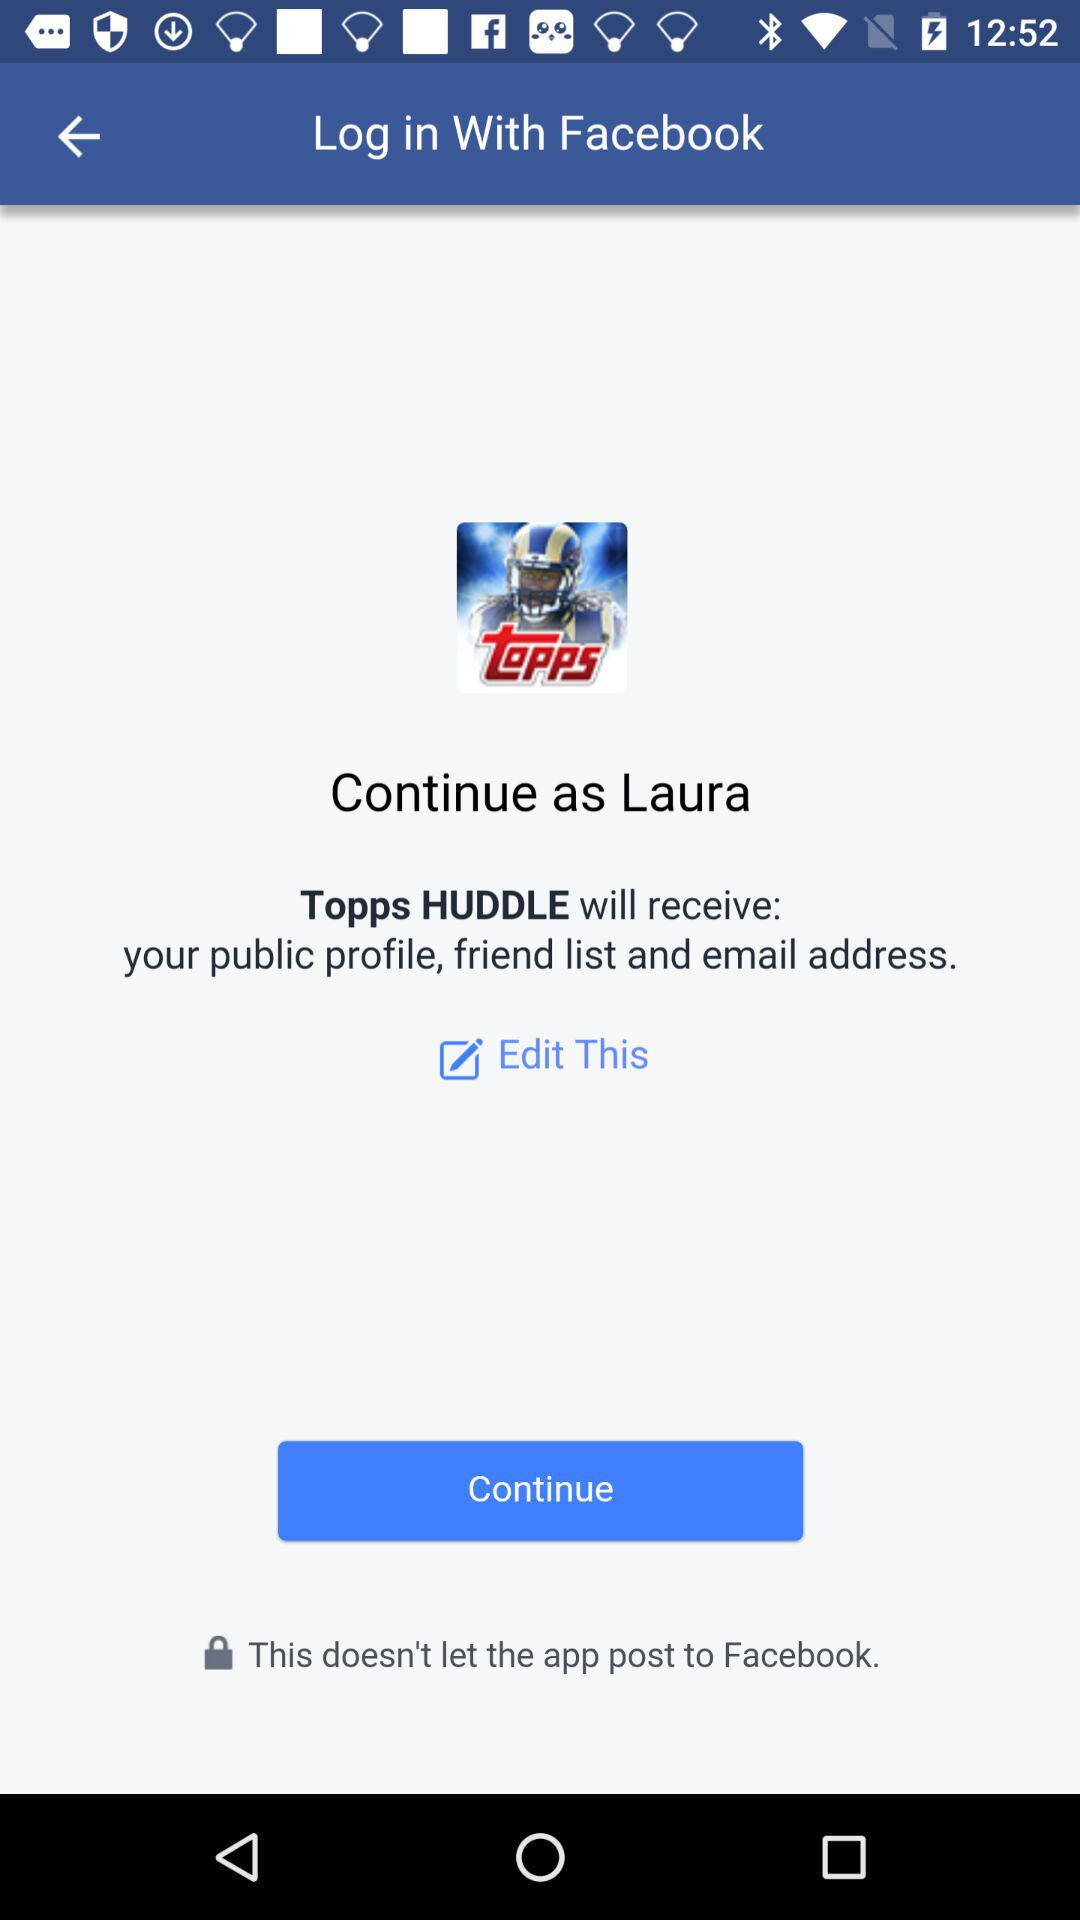What application is asking for permission? The application asking for permission is "Topps HUDDLE". 